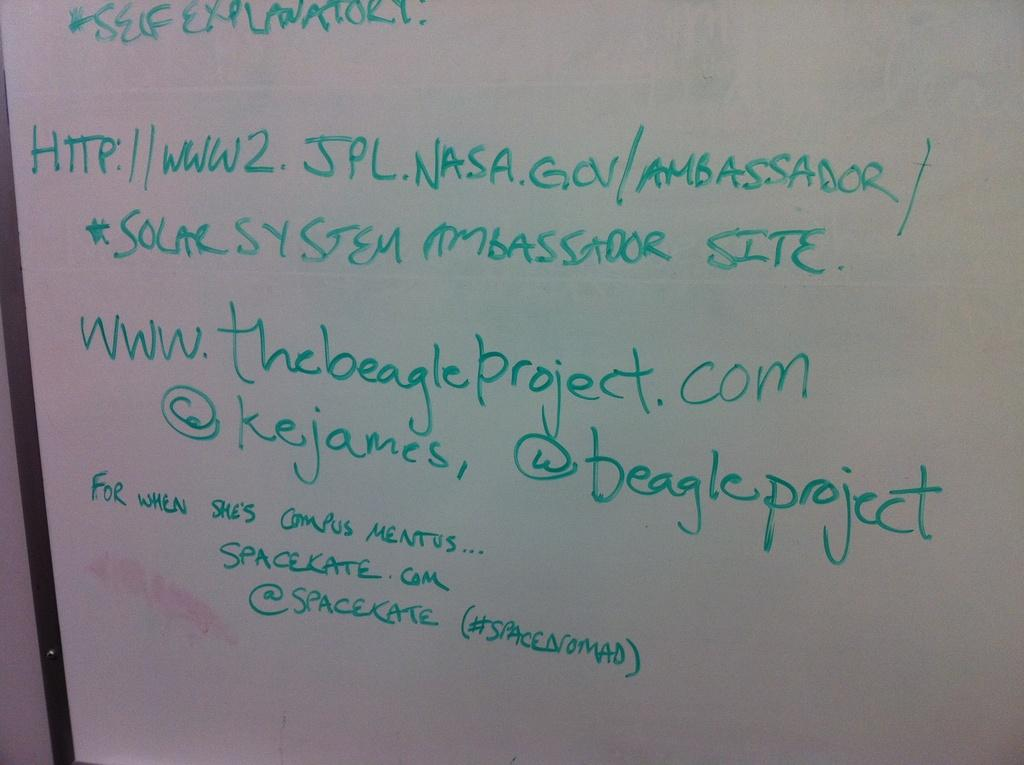<image>
Share a concise interpretation of the image provided. The ambassador of Solar System and the beagle project is sharing her site information. 